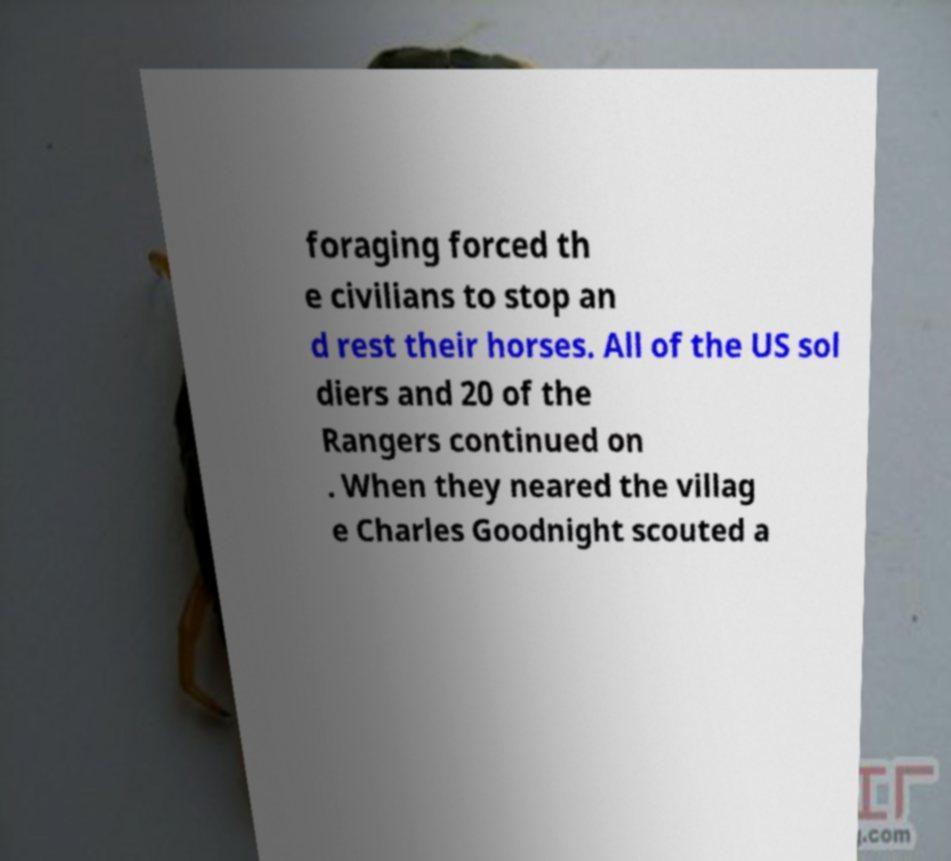Please identify and transcribe the text found in this image. foraging forced th e civilians to stop an d rest their horses. All of the US sol diers and 20 of the Rangers continued on . When they neared the villag e Charles Goodnight scouted a 